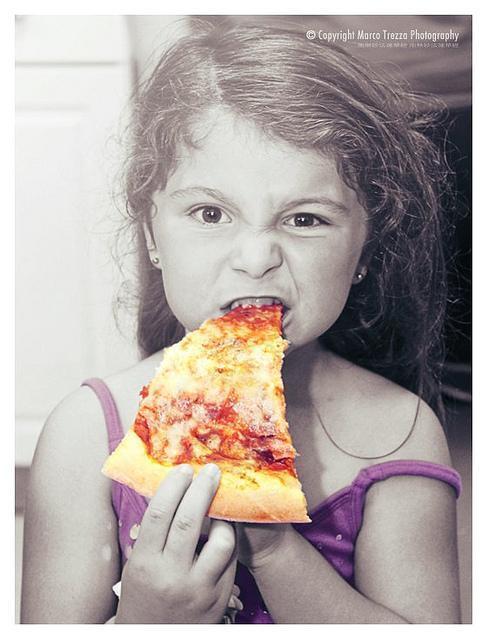Verify the accuracy of this image caption: "The pizza is touching the person.".
Answer yes or no. Yes. 